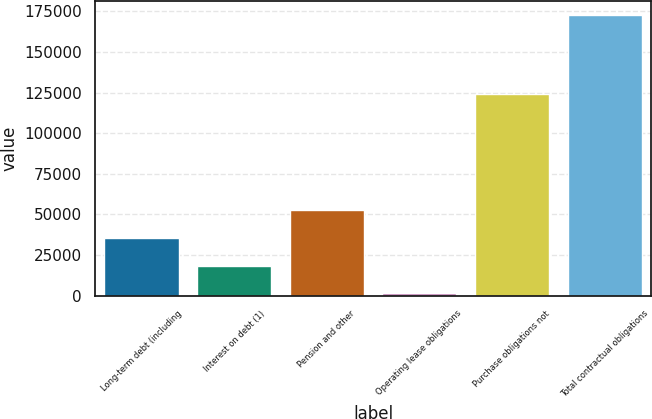<chart> <loc_0><loc_0><loc_500><loc_500><bar_chart><fcel>Long-term debt (including<fcel>Interest on debt (1)<fcel>Pension and other<fcel>Operating lease obligations<fcel>Purchase obligations not<fcel>Total contractual obligations<nl><fcel>35661.8<fcel>18537.9<fcel>52785.7<fcel>1414<fcel>123904<fcel>172653<nl></chart> 